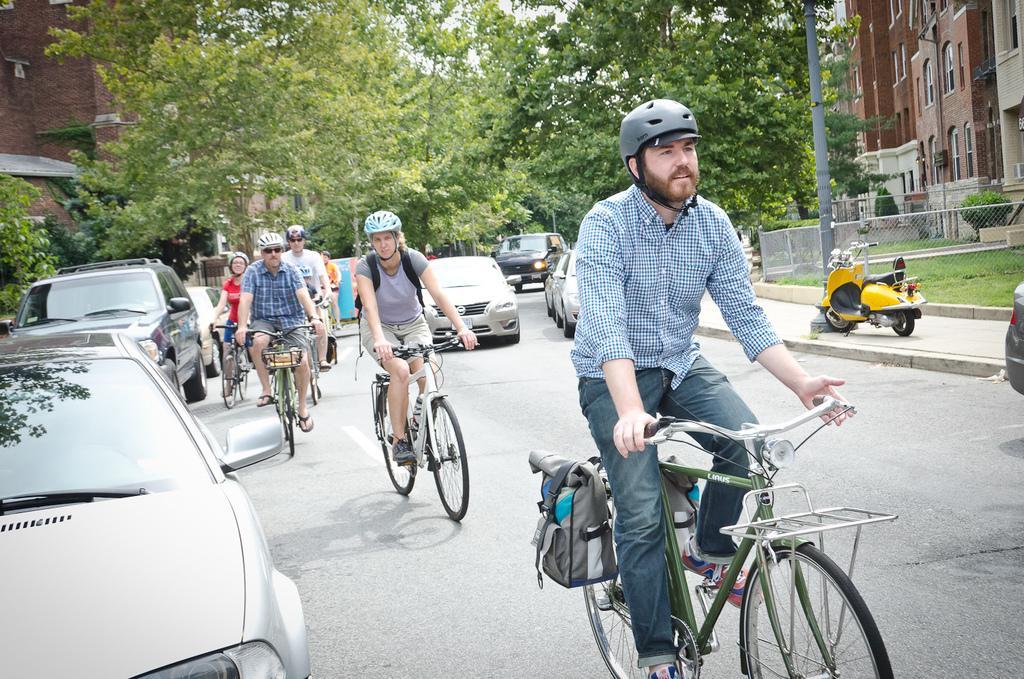Could you give a brief overview of what you see in this image? In this picture we can see men and women wore helmets riding bicycles on road and we have cars on road and beside to this there is foot path scooter on it and in background we can see trees, building with windows, fence, grass. 